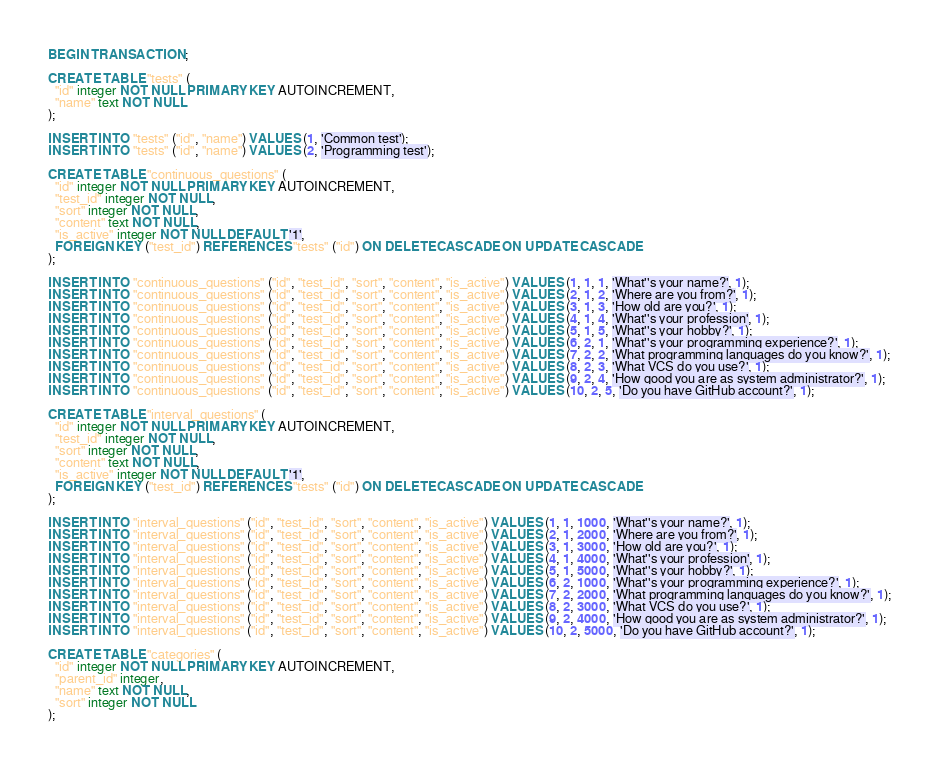<code> <loc_0><loc_0><loc_500><loc_500><_SQL_>BEGIN TRANSACTION;

CREATE TABLE "tests" (
  "id" integer NOT NULL PRIMARY KEY AUTOINCREMENT,
  "name" text NOT NULL
);

INSERT INTO "tests" ("id", "name") VALUES (1, 'Common test');
INSERT INTO "tests" ("id", "name") VALUES (2, 'Programming test');

CREATE TABLE "continuous_questions" (
  "id" integer NOT NULL PRIMARY KEY AUTOINCREMENT,
  "test_id" integer NOT NULL,
  "sort" integer NOT NULL,
  "content" text NOT NULL,
  "is_active" integer NOT NULL DEFAULT '1',
  FOREIGN KEY ("test_id") REFERENCES "tests" ("id") ON DELETE CASCADE ON UPDATE CASCADE
);

INSERT INTO "continuous_questions" ("id", "test_id", "sort", "content", "is_active") VALUES (1, 1, 1, 'What''s your name?', 1);
INSERT INTO "continuous_questions" ("id", "test_id", "sort", "content", "is_active") VALUES (2, 1, 2, 'Where are you from?', 1);
INSERT INTO "continuous_questions" ("id", "test_id", "sort", "content", "is_active") VALUES (3, 1, 3, 'How old are you?', 1);
INSERT INTO "continuous_questions" ("id", "test_id", "sort", "content", "is_active") VALUES (4, 1, 4, 'What''s your profession', 1);
INSERT INTO "continuous_questions" ("id", "test_id", "sort", "content", "is_active") VALUES (5, 1, 5, 'What''s your hobby?', 1);
INSERT INTO "continuous_questions" ("id", "test_id", "sort", "content", "is_active") VALUES (6, 2, 1, 'What''s your programming experience?', 1);
INSERT INTO "continuous_questions" ("id", "test_id", "sort", "content", "is_active") VALUES (7, 2, 2, 'What programming languages do you know?', 1);
INSERT INTO "continuous_questions" ("id", "test_id", "sort", "content", "is_active") VALUES (8, 2, 3, 'What VCS do you use?', 1);
INSERT INTO "continuous_questions" ("id", "test_id", "sort", "content", "is_active") VALUES (9, 2, 4, 'How good you are as system administrator?', 1);
INSERT INTO "continuous_questions" ("id", "test_id", "sort", "content", "is_active") VALUES (10, 2, 5, 'Do you have GitHub account?', 1);

CREATE TABLE "interval_questions" (
  "id" integer NOT NULL PRIMARY KEY AUTOINCREMENT,
  "test_id" integer NOT NULL,
  "sort" integer NOT NULL,
  "content" text NOT NULL,
  "is_active" integer NOT NULL DEFAULT '1',
  FOREIGN KEY ("test_id") REFERENCES "tests" ("id") ON DELETE CASCADE ON UPDATE CASCADE
);

INSERT INTO "interval_questions" ("id", "test_id", "sort", "content", "is_active") VALUES (1, 1, 1000, 'What''s your name?', 1);
INSERT INTO "interval_questions" ("id", "test_id", "sort", "content", "is_active") VALUES (2, 1, 2000, 'Where are you from?', 1);
INSERT INTO "interval_questions" ("id", "test_id", "sort", "content", "is_active") VALUES (3, 1, 3000, 'How old are you?', 1);
INSERT INTO "interval_questions" ("id", "test_id", "sort", "content", "is_active") VALUES (4, 1, 4000, 'What''s your profession', 1);
INSERT INTO "interval_questions" ("id", "test_id", "sort", "content", "is_active") VALUES (5, 1, 5000, 'What''s your hobby?', 1);
INSERT INTO "interval_questions" ("id", "test_id", "sort", "content", "is_active") VALUES (6, 2, 1000, 'What''s your programming experience?', 1);
INSERT INTO "interval_questions" ("id", "test_id", "sort", "content", "is_active") VALUES (7, 2, 2000, 'What programming languages do you know?', 1);
INSERT INTO "interval_questions" ("id", "test_id", "sort", "content", "is_active") VALUES (8, 2, 3000, 'What VCS do you use?', 1);
INSERT INTO "interval_questions" ("id", "test_id", "sort", "content", "is_active") VALUES (9, 2, 4000, 'How good you are as system administrator?', 1);
INSERT INTO "interval_questions" ("id", "test_id", "sort", "content", "is_active") VALUES (10, 2, 5000, 'Do you have GitHub account?', 1);

CREATE TABLE "categories" (
  "id" integer NOT NULL PRIMARY KEY AUTOINCREMENT,
  "parent_id" integer,
  "name" text NOT NULL,
  "sort" integer NOT NULL
);
</code> 